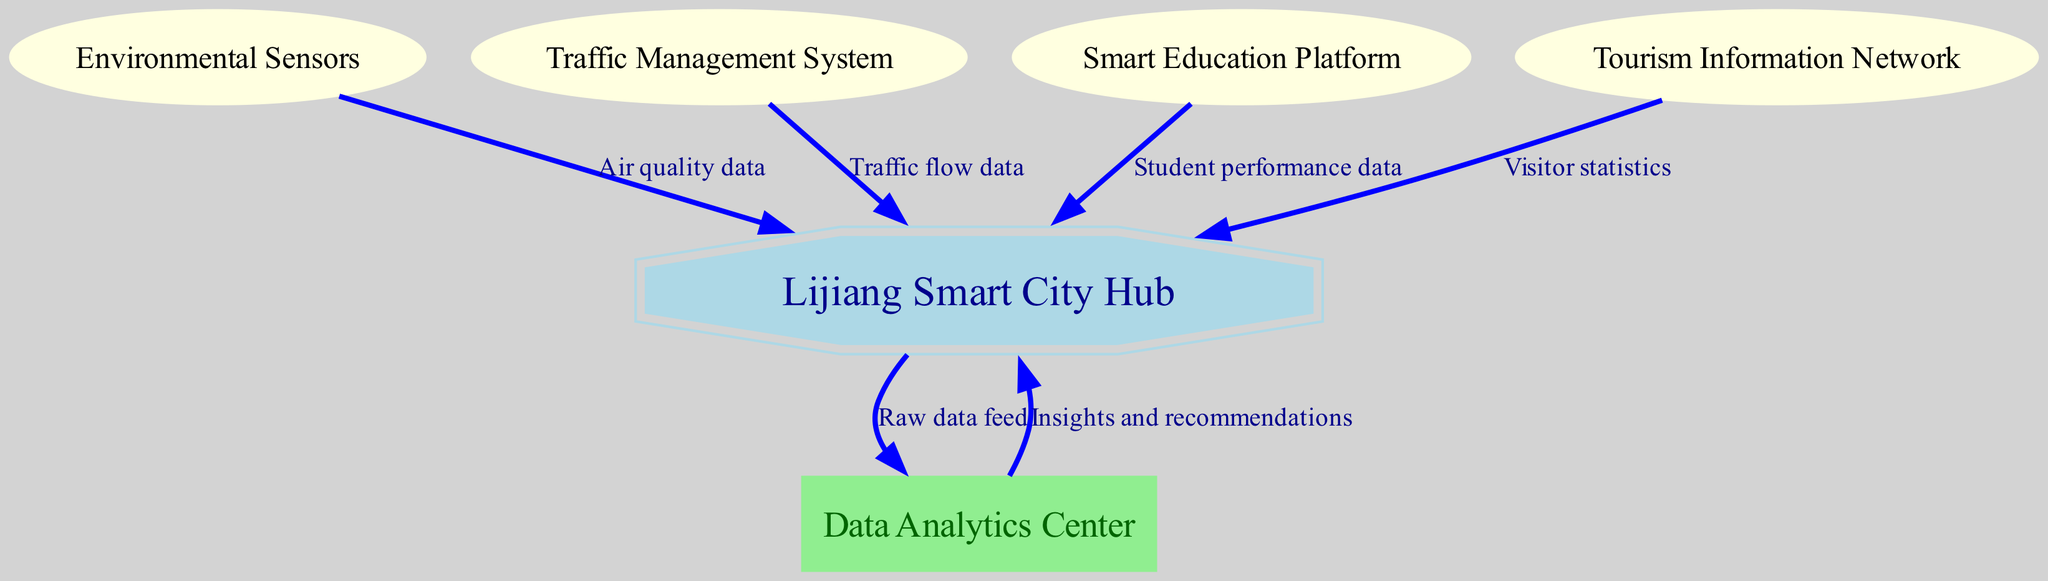What is the total number of nodes in the diagram? The diagram contains a list of nodes: Lijiang Smart City Hub, Environmental Sensors, Traffic Management System, Smart Education Platform, Tourism Information Network, and Data Analytics Center. Counting these gives a total of 6 nodes.
Answer: 6 What type of data does the Environmental Sensors node provide? The edge from Environmental Sensors to Lijiang Smart City Hub is labeled as "Air quality data," which indicates the type of data being provided.
Answer: Air quality data Which node receives traffic flow data? The Traffic Management System node sends data to the Lijiang Smart City Hub, as shown by the directed edge labeled "Traffic flow data." This indicates that the Lijiang Smart City Hub is the receiving node.
Answer: Lijiang Smart City Hub What is the purpose of the Data Analytics Center? The edges indicate that the Data Analytics Center receives raw data feeds from the Lijiang Smart City Hub and provides insights and recommendations back to the hub. Therefore, its purpose is data analysis and generating actionable insights.
Answer: Data analysis How many edges are present in the diagram? The diagram has several connecting edges: one from Environmental Sensors, one from Traffic Management System, one from Smart Education Platform, one from Tourism Information Network, one from Lijiang Smart City Hub to Data Analytics Center, and one back to the hub. Counting these gives a total of 6 edges.
Answer: 6 What type of platform is represented by node 4? The node labeled "Smart Education Platform" suggests that it's an education-oriented platform within the smart city infrastructure, focusing on enhancing educational outcomes using technology.
Answer: Education platform What are the two types of data exchange between the Lijiang Smart City Hub and the Data Analytics Center? The Lijiang Smart City Hub sends "Raw data feed" to the Data Analytics Center, and in return, it receives "Insights and recommendations." This indicates a bi-directional flow of data for analysis and utility.
Answer: Raw data and insights Which node does the Tourism Information Network provide statistics to? The edge from the Tourism Information Network indicates it provides "Visitor statistics" to the Lijiang Smart City Hub, making the hub the receiver of this data.
Answer: Lijiang Smart City Hub 